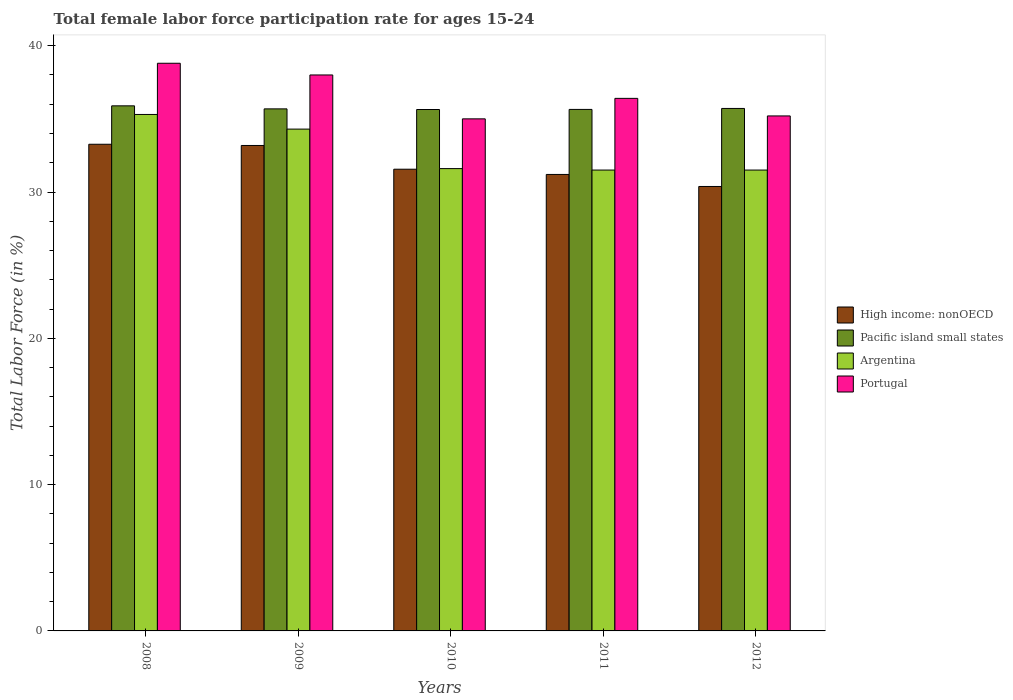Are the number of bars on each tick of the X-axis equal?
Your response must be concise. Yes. How many bars are there on the 5th tick from the left?
Offer a terse response. 4. How many bars are there on the 2nd tick from the right?
Make the answer very short. 4. In how many cases, is the number of bars for a given year not equal to the number of legend labels?
Your response must be concise. 0. What is the female labor force participation rate in Portugal in 2011?
Give a very brief answer. 36.4. Across all years, what is the maximum female labor force participation rate in High income: nonOECD?
Your response must be concise. 33.26. Across all years, what is the minimum female labor force participation rate in High income: nonOECD?
Provide a succinct answer. 30.38. In which year was the female labor force participation rate in High income: nonOECD minimum?
Make the answer very short. 2012. What is the total female labor force participation rate in Argentina in the graph?
Provide a short and direct response. 164.2. What is the difference between the female labor force participation rate in Argentina in 2010 and that in 2012?
Make the answer very short. 0.1. What is the difference between the female labor force participation rate in Pacific island small states in 2009 and the female labor force participation rate in Portugal in 2012?
Offer a terse response. 0.48. What is the average female labor force participation rate in Portugal per year?
Ensure brevity in your answer.  36.68. In the year 2009, what is the difference between the female labor force participation rate in Argentina and female labor force participation rate in High income: nonOECD?
Provide a short and direct response. 1.12. In how many years, is the female labor force participation rate in Argentina greater than 8 %?
Make the answer very short. 5. What is the ratio of the female labor force participation rate in High income: nonOECD in 2011 to that in 2012?
Make the answer very short. 1.03. Is the female labor force participation rate in High income: nonOECD in 2009 less than that in 2010?
Give a very brief answer. No. Is the difference between the female labor force participation rate in Argentina in 2008 and 2010 greater than the difference between the female labor force participation rate in High income: nonOECD in 2008 and 2010?
Make the answer very short. Yes. What is the difference between the highest and the second highest female labor force participation rate in Portugal?
Offer a terse response. 0.8. What is the difference between the highest and the lowest female labor force participation rate in Pacific island small states?
Your answer should be compact. 0.25. Is it the case that in every year, the sum of the female labor force participation rate in Argentina and female labor force participation rate in Portugal is greater than the sum of female labor force participation rate in High income: nonOECD and female labor force participation rate in Pacific island small states?
Ensure brevity in your answer.  Yes. What does the 3rd bar from the left in 2011 represents?
Make the answer very short. Argentina. How many years are there in the graph?
Your response must be concise. 5. Are the values on the major ticks of Y-axis written in scientific E-notation?
Provide a succinct answer. No. Does the graph contain any zero values?
Ensure brevity in your answer.  No. Where does the legend appear in the graph?
Provide a succinct answer. Center right. How many legend labels are there?
Your answer should be compact. 4. How are the legend labels stacked?
Offer a very short reply. Vertical. What is the title of the graph?
Provide a short and direct response. Total female labor force participation rate for ages 15-24. Does "Sudan" appear as one of the legend labels in the graph?
Your response must be concise. No. What is the label or title of the Y-axis?
Your answer should be compact. Total Labor Force (in %). What is the Total Labor Force (in %) of High income: nonOECD in 2008?
Make the answer very short. 33.26. What is the Total Labor Force (in %) of Pacific island small states in 2008?
Make the answer very short. 35.89. What is the Total Labor Force (in %) in Argentina in 2008?
Ensure brevity in your answer.  35.3. What is the Total Labor Force (in %) in Portugal in 2008?
Give a very brief answer. 38.8. What is the Total Labor Force (in %) of High income: nonOECD in 2009?
Your answer should be compact. 33.18. What is the Total Labor Force (in %) in Pacific island small states in 2009?
Your response must be concise. 35.68. What is the Total Labor Force (in %) of Argentina in 2009?
Provide a succinct answer. 34.3. What is the Total Labor Force (in %) in Portugal in 2009?
Offer a very short reply. 38. What is the Total Labor Force (in %) in High income: nonOECD in 2010?
Offer a very short reply. 31.56. What is the Total Labor Force (in %) in Pacific island small states in 2010?
Offer a very short reply. 35.64. What is the Total Labor Force (in %) of Argentina in 2010?
Your response must be concise. 31.6. What is the Total Labor Force (in %) of High income: nonOECD in 2011?
Provide a succinct answer. 31.2. What is the Total Labor Force (in %) of Pacific island small states in 2011?
Ensure brevity in your answer.  35.64. What is the Total Labor Force (in %) in Argentina in 2011?
Your response must be concise. 31.5. What is the Total Labor Force (in %) in Portugal in 2011?
Make the answer very short. 36.4. What is the Total Labor Force (in %) in High income: nonOECD in 2012?
Provide a succinct answer. 30.38. What is the Total Labor Force (in %) of Pacific island small states in 2012?
Your response must be concise. 35.71. What is the Total Labor Force (in %) of Argentina in 2012?
Your response must be concise. 31.5. What is the Total Labor Force (in %) in Portugal in 2012?
Provide a succinct answer. 35.2. Across all years, what is the maximum Total Labor Force (in %) in High income: nonOECD?
Your answer should be very brief. 33.26. Across all years, what is the maximum Total Labor Force (in %) in Pacific island small states?
Your answer should be compact. 35.89. Across all years, what is the maximum Total Labor Force (in %) in Argentina?
Ensure brevity in your answer.  35.3. Across all years, what is the maximum Total Labor Force (in %) in Portugal?
Offer a terse response. 38.8. Across all years, what is the minimum Total Labor Force (in %) of High income: nonOECD?
Your answer should be compact. 30.38. Across all years, what is the minimum Total Labor Force (in %) in Pacific island small states?
Keep it short and to the point. 35.64. Across all years, what is the minimum Total Labor Force (in %) of Argentina?
Keep it short and to the point. 31.5. What is the total Total Labor Force (in %) in High income: nonOECD in the graph?
Your answer should be compact. 159.58. What is the total Total Labor Force (in %) of Pacific island small states in the graph?
Offer a terse response. 178.57. What is the total Total Labor Force (in %) in Argentina in the graph?
Your answer should be very brief. 164.2. What is the total Total Labor Force (in %) of Portugal in the graph?
Your response must be concise. 183.4. What is the difference between the Total Labor Force (in %) in High income: nonOECD in 2008 and that in 2009?
Your answer should be compact. 0.08. What is the difference between the Total Labor Force (in %) of Pacific island small states in 2008 and that in 2009?
Give a very brief answer. 0.21. What is the difference between the Total Labor Force (in %) of Argentina in 2008 and that in 2009?
Provide a succinct answer. 1. What is the difference between the Total Labor Force (in %) in Portugal in 2008 and that in 2009?
Provide a short and direct response. 0.8. What is the difference between the Total Labor Force (in %) in High income: nonOECD in 2008 and that in 2010?
Keep it short and to the point. 1.71. What is the difference between the Total Labor Force (in %) of Pacific island small states in 2008 and that in 2010?
Offer a very short reply. 0.25. What is the difference between the Total Labor Force (in %) of Argentina in 2008 and that in 2010?
Offer a very short reply. 3.7. What is the difference between the Total Labor Force (in %) in Portugal in 2008 and that in 2010?
Give a very brief answer. 3.8. What is the difference between the Total Labor Force (in %) of High income: nonOECD in 2008 and that in 2011?
Your answer should be compact. 2.06. What is the difference between the Total Labor Force (in %) of Pacific island small states in 2008 and that in 2011?
Give a very brief answer. 0.25. What is the difference between the Total Labor Force (in %) of Portugal in 2008 and that in 2011?
Your answer should be compact. 2.4. What is the difference between the Total Labor Force (in %) of High income: nonOECD in 2008 and that in 2012?
Make the answer very short. 2.89. What is the difference between the Total Labor Force (in %) in Pacific island small states in 2008 and that in 2012?
Ensure brevity in your answer.  0.18. What is the difference between the Total Labor Force (in %) of Argentina in 2008 and that in 2012?
Provide a succinct answer. 3.8. What is the difference between the Total Labor Force (in %) of High income: nonOECD in 2009 and that in 2010?
Your answer should be very brief. 1.62. What is the difference between the Total Labor Force (in %) of Pacific island small states in 2009 and that in 2010?
Your answer should be very brief. 0.04. What is the difference between the Total Labor Force (in %) of Argentina in 2009 and that in 2010?
Your answer should be compact. 2.7. What is the difference between the Total Labor Force (in %) in High income: nonOECD in 2009 and that in 2011?
Provide a succinct answer. 1.98. What is the difference between the Total Labor Force (in %) of Pacific island small states in 2009 and that in 2011?
Provide a succinct answer. 0.04. What is the difference between the Total Labor Force (in %) in High income: nonOECD in 2009 and that in 2012?
Keep it short and to the point. 2.8. What is the difference between the Total Labor Force (in %) in Pacific island small states in 2009 and that in 2012?
Your answer should be very brief. -0.03. What is the difference between the Total Labor Force (in %) in Argentina in 2009 and that in 2012?
Ensure brevity in your answer.  2.8. What is the difference between the Total Labor Force (in %) in High income: nonOECD in 2010 and that in 2011?
Ensure brevity in your answer.  0.36. What is the difference between the Total Labor Force (in %) in Pacific island small states in 2010 and that in 2011?
Your answer should be very brief. -0.01. What is the difference between the Total Labor Force (in %) of Portugal in 2010 and that in 2011?
Provide a short and direct response. -1.4. What is the difference between the Total Labor Force (in %) of High income: nonOECD in 2010 and that in 2012?
Your answer should be very brief. 1.18. What is the difference between the Total Labor Force (in %) in Pacific island small states in 2010 and that in 2012?
Ensure brevity in your answer.  -0.07. What is the difference between the Total Labor Force (in %) of Portugal in 2010 and that in 2012?
Give a very brief answer. -0.2. What is the difference between the Total Labor Force (in %) of High income: nonOECD in 2011 and that in 2012?
Keep it short and to the point. 0.82. What is the difference between the Total Labor Force (in %) of Pacific island small states in 2011 and that in 2012?
Give a very brief answer. -0.07. What is the difference between the Total Labor Force (in %) in Argentina in 2011 and that in 2012?
Your answer should be compact. 0. What is the difference between the Total Labor Force (in %) of High income: nonOECD in 2008 and the Total Labor Force (in %) of Pacific island small states in 2009?
Offer a very short reply. -2.42. What is the difference between the Total Labor Force (in %) of High income: nonOECD in 2008 and the Total Labor Force (in %) of Argentina in 2009?
Give a very brief answer. -1.04. What is the difference between the Total Labor Force (in %) in High income: nonOECD in 2008 and the Total Labor Force (in %) in Portugal in 2009?
Offer a very short reply. -4.74. What is the difference between the Total Labor Force (in %) in Pacific island small states in 2008 and the Total Labor Force (in %) in Argentina in 2009?
Your answer should be compact. 1.59. What is the difference between the Total Labor Force (in %) in Pacific island small states in 2008 and the Total Labor Force (in %) in Portugal in 2009?
Offer a terse response. -2.11. What is the difference between the Total Labor Force (in %) of Argentina in 2008 and the Total Labor Force (in %) of Portugal in 2009?
Keep it short and to the point. -2.7. What is the difference between the Total Labor Force (in %) in High income: nonOECD in 2008 and the Total Labor Force (in %) in Pacific island small states in 2010?
Provide a short and direct response. -2.38. What is the difference between the Total Labor Force (in %) in High income: nonOECD in 2008 and the Total Labor Force (in %) in Argentina in 2010?
Ensure brevity in your answer.  1.66. What is the difference between the Total Labor Force (in %) of High income: nonOECD in 2008 and the Total Labor Force (in %) of Portugal in 2010?
Offer a very short reply. -1.74. What is the difference between the Total Labor Force (in %) of Pacific island small states in 2008 and the Total Labor Force (in %) of Argentina in 2010?
Make the answer very short. 4.29. What is the difference between the Total Labor Force (in %) in Pacific island small states in 2008 and the Total Labor Force (in %) in Portugal in 2010?
Offer a terse response. 0.89. What is the difference between the Total Labor Force (in %) of High income: nonOECD in 2008 and the Total Labor Force (in %) of Pacific island small states in 2011?
Ensure brevity in your answer.  -2.38. What is the difference between the Total Labor Force (in %) in High income: nonOECD in 2008 and the Total Labor Force (in %) in Argentina in 2011?
Make the answer very short. 1.76. What is the difference between the Total Labor Force (in %) of High income: nonOECD in 2008 and the Total Labor Force (in %) of Portugal in 2011?
Give a very brief answer. -3.14. What is the difference between the Total Labor Force (in %) of Pacific island small states in 2008 and the Total Labor Force (in %) of Argentina in 2011?
Offer a terse response. 4.39. What is the difference between the Total Labor Force (in %) of Pacific island small states in 2008 and the Total Labor Force (in %) of Portugal in 2011?
Make the answer very short. -0.51. What is the difference between the Total Labor Force (in %) in Argentina in 2008 and the Total Labor Force (in %) in Portugal in 2011?
Your response must be concise. -1.1. What is the difference between the Total Labor Force (in %) of High income: nonOECD in 2008 and the Total Labor Force (in %) of Pacific island small states in 2012?
Ensure brevity in your answer.  -2.45. What is the difference between the Total Labor Force (in %) in High income: nonOECD in 2008 and the Total Labor Force (in %) in Argentina in 2012?
Make the answer very short. 1.76. What is the difference between the Total Labor Force (in %) in High income: nonOECD in 2008 and the Total Labor Force (in %) in Portugal in 2012?
Make the answer very short. -1.94. What is the difference between the Total Labor Force (in %) in Pacific island small states in 2008 and the Total Labor Force (in %) in Argentina in 2012?
Provide a short and direct response. 4.39. What is the difference between the Total Labor Force (in %) in Pacific island small states in 2008 and the Total Labor Force (in %) in Portugal in 2012?
Make the answer very short. 0.69. What is the difference between the Total Labor Force (in %) of Argentina in 2008 and the Total Labor Force (in %) of Portugal in 2012?
Give a very brief answer. 0.1. What is the difference between the Total Labor Force (in %) in High income: nonOECD in 2009 and the Total Labor Force (in %) in Pacific island small states in 2010?
Your answer should be compact. -2.46. What is the difference between the Total Labor Force (in %) in High income: nonOECD in 2009 and the Total Labor Force (in %) in Argentina in 2010?
Your response must be concise. 1.58. What is the difference between the Total Labor Force (in %) in High income: nonOECD in 2009 and the Total Labor Force (in %) in Portugal in 2010?
Your response must be concise. -1.82. What is the difference between the Total Labor Force (in %) in Pacific island small states in 2009 and the Total Labor Force (in %) in Argentina in 2010?
Make the answer very short. 4.08. What is the difference between the Total Labor Force (in %) of Pacific island small states in 2009 and the Total Labor Force (in %) of Portugal in 2010?
Your answer should be very brief. 0.68. What is the difference between the Total Labor Force (in %) of High income: nonOECD in 2009 and the Total Labor Force (in %) of Pacific island small states in 2011?
Provide a succinct answer. -2.46. What is the difference between the Total Labor Force (in %) in High income: nonOECD in 2009 and the Total Labor Force (in %) in Argentina in 2011?
Ensure brevity in your answer.  1.68. What is the difference between the Total Labor Force (in %) in High income: nonOECD in 2009 and the Total Labor Force (in %) in Portugal in 2011?
Offer a very short reply. -3.22. What is the difference between the Total Labor Force (in %) in Pacific island small states in 2009 and the Total Labor Force (in %) in Argentina in 2011?
Offer a terse response. 4.18. What is the difference between the Total Labor Force (in %) of Pacific island small states in 2009 and the Total Labor Force (in %) of Portugal in 2011?
Give a very brief answer. -0.72. What is the difference between the Total Labor Force (in %) of High income: nonOECD in 2009 and the Total Labor Force (in %) of Pacific island small states in 2012?
Offer a terse response. -2.53. What is the difference between the Total Labor Force (in %) in High income: nonOECD in 2009 and the Total Labor Force (in %) in Argentina in 2012?
Keep it short and to the point. 1.68. What is the difference between the Total Labor Force (in %) of High income: nonOECD in 2009 and the Total Labor Force (in %) of Portugal in 2012?
Offer a very short reply. -2.02. What is the difference between the Total Labor Force (in %) of Pacific island small states in 2009 and the Total Labor Force (in %) of Argentina in 2012?
Give a very brief answer. 4.18. What is the difference between the Total Labor Force (in %) in Pacific island small states in 2009 and the Total Labor Force (in %) in Portugal in 2012?
Your answer should be compact. 0.48. What is the difference between the Total Labor Force (in %) of Argentina in 2009 and the Total Labor Force (in %) of Portugal in 2012?
Make the answer very short. -0.9. What is the difference between the Total Labor Force (in %) in High income: nonOECD in 2010 and the Total Labor Force (in %) in Pacific island small states in 2011?
Make the answer very short. -4.09. What is the difference between the Total Labor Force (in %) in High income: nonOECD in 2010 and the Total Labor Force (in %) in Argentina in 2011?
Ensure brevity in your answer.  0.06. What is the difference between the Total Labor Force (in %) in High income: nonOECD in 2010 and the Total Labor Force (in %) in Portugal in 2011?
Your answer should be compact. -4.84. What is the difference between the Total Labor Force (in %) of Pacific island small states in 2010 and the Total Labor Force (in %) of Argentina in 2011?
Make the answer very short. 4.14. What is the difference between the Total Labor Force (in %) in Pacific island small states in 2010 and the Total Labor Force (in %) in Portugal in 2011?
Your answer should be very brief. -0.76. What is the difference between the Total Labor Force (in %) of Argentina in 2010 and the Total Labor Force (in %) of Portugal in 2011?
Your response must be concise. -4.8. What is the difference between the Total Labor Force (in %) of High income: nonOECD in 2010 and the Total Labor Force (in %) of Pacific island small states in 2012?
Provide a short and direct response. -4.15. What is the difference between the Total Labor Force (in %) of High income: nonOECD in 2010 and the Total Labor Force (in %) of Argentina in 2012?
Your response must be concise. 0.06. What is the difference between the Total Labor Force (in %) in High income: nonOECD in 2010 and the Total Labor Force (in %) in Portugal in 2012?
Offer a very short reply. -3.64. What is the difference between the Total Labor Force (in %) of Pacific island small states in 2010 and the Total Labor Force (in %) of Argentina in 2012?
Your answer should be compact. 4.14. What is the difference between the Total Labor Force (in %) in Pacific island small states in 2010 and the Total Labor Force (in %) in Portugal in 2012?
Your response must be concise. 0.44. What is the difference between the Total Labor Force (in %) of High income: nonOECD in 2011 and the Total Labor Force (in %) of Pacific island small states in 2012?
Your response must be concise. -4.51. What is the difference between the Total Labor Force (in %) of High income: nonOECD in 2011 and the Total Labor Force (in %) of Argentina in 2012?
Ensure brevity in your answer.  -0.3. What is the difference between the Total Labor Force (in %) of High income: nonOECD in 2011 and the Total Labor Force (in %) of Portugal in 2012?
Give a very brief answer. -4. What is the difference between the Total Labor Force (in %) of Pacific island small states in 2011 and the Total Labor Force (in %) of Argentina in 2012?
Your response must be concise. 4.14. What is the difference between the Total Labor Force (in %) of Pacific island small states in 2011 and the Total Labor Force (in %) of Portugal in 2012?
Provide a succinct answer. 0.44. What is the difference between the Total Labor Force (in %) in Argentina in 2011 and the Total Labor Force (in %) in Portugal in 2012?
Offer a terse response. -3.7. What is the average Total Labor Force (in %) of High income: nonOECD per year?
Offer a very short reply. 31.92. What is the average Total Labor Force (in %) in Pacific island small states per year?
Your answer should be compact. 35.71. What is the average Total Labor Force (in %) in Argentina per year?
Make the answer very short. 32.84. What is the average Total Labor Force (in %) in Portugal per year?
Keep it short and to the point. 36.68. In the year 2008, what is the difference between the Total Labor Force (in %) in High income: nonOECD and Total Labor Force (in %) in Pacific island small states?
Offer a terse response. -2.63. In the year 2008, what is the difference between the Total Labor Force (in %) in High income: nonOECD and Total Labor Force (in %) in Argentina?
Your answer should be compact. -2.04. In the year 2008, what is the difference between the Total Labor Force (in %) in High income: nonOECD and Total Labor Force (in %) in Portugal?
Your answer should be compact. -5.54. In the year 2008, what is the difference between the Total Labor Force (in %) of Pacific island small states and Total Labor Force (in %) of Argentina?
Ensure brevity in your answer.  0.59. In the year 2008, what is the difference between the Total Labor Force (in %) in Pacific island small states and Total Labor Force (in %) in Portugal?
Ensure brevity in your answer.  -2.91. In the year 2008, what is the difference between the Total Labor Force (in %) in Argentina and Total Labor Force (in %) in Portugal?
Provide a succinct answer. -3.5. In the year 2009, what is the difference between the Total Labor Force (in %) of High income: nonOECD and Total Labor Force (in %) of Pacific island small states?
Keep it short and to the point. -2.5. In the year 2009, what is the difference between the Total Labor Force (in %) of High income: nonOECD and Total Labor Force (in %) of Argentina?
Ensure brevity in your answer.  -1.12. In the year 2009, what is the difference between the Total Labor Force (in %) in High income: nonOECD and Total Labor Force (in %) in Portugal?
Provide a short and direct response. -4.82. In the year 2009, what is the difference between the Total Labor Force (in %) of Pacific island small states and Total Labor Force (in %) of Argentina?
Your answer should be very brief. 1.38. In the year 2009, what is the difference between the Total Labor Force (in %) of Pacific island small states and Total Labor Force (in %) of Portugal?
Provide a short and direct response. -2.32. In the year 2009, what is the difference between the Total Labor Force (in %) in Argentina and Total Labor Force (in %) in Portugal?
Provide a short and direct response. -3.7. In the year 2010, what is the difference between the Total Labor Force (in %) in High income: nonOECD and Total Labor Force (in %) in Pacific island small states?
Your answer should be very brief. -4.08. In the year 2010, what is the difference between the Total Labor Force (in %) of High income: nonOECD and Total Labor Force (in %) of Argentina?
Offer a terse response. -0.04. In the year 2010, what is the difference between the Total Labor Force (in %) in High income: nonOECD and Total Labor Force (in %) in Portugal?
Make the answer very short. -3.44. In the year 2010, what is the difference between the Total Labor Force (in %) of Pacific island small states and Total Labor Force (in %) of Argentina?
Provide a succinct answer. 4.04. In the year 2010, what is the difference between the Total Labor Force (in %) of Pacific island small states and Total Labor Force (in %) of Portugal?
Keep it short and to the point. 0.64. In the year 2010, what is the difference between the Total Labor Force (in %) of Argentina and Total Labor Force (in %) of Portugal?
Make the answer very short. -3.4. In the year 2011, what is the difference between the Total Labor Force (in %) of High income: nonOECD and Total Labor Force (in %) of Pacific island small states?
Ensure brevity in your answer.  -4.44. In the year 2011, what is the difference between the Total Labor Force (in %) of High income: nonOECD and Total Labor Force (in %) of Argentina?
Provide a short and direct response. -0.3. In the year 2011, what is the difference between the Total Labor Force (in %) in High income: nonOECD and Total Labor Force (in %) in Portugal?
Ensure brevity in your answer.  -5.2. In the year 2011, what is the difference between the Total Labor Force (in %) of Pacific island small states and Total Labor Force (in %) of Argentina?
Provide a short and direct response. 4.14. In the year 2011, what is the difference between the Total Labor Force (in %) of Pacific island small states and Total Labor Force (in %) of Portugal?
Offer a very short reply. -0.76. In the year 2011, what is the difference between the Total Labor Force (in %) in Argentina and Total Labor Force (in %) in Portugal?
Make the answer very short. -4.9. In the year 2012, what is the difference between the Total Labor Force (in %) in High income: nonOECD and Total Labor Force (in %) in Pacific island small states?
Provide a short and direct response. -5.33. In the year 2012, what is the difference between the Total Labor Force (in %) of High income: nonOECD and Total Labor Force (in %) of Argentina?
Make the answer very short. -1.12. In the year 2012, what is the difference between the Total Labor Force (in %) in High income: nonOECD and Total Labor Force (in %) in Portugal?
Ensure brevity in your answer.  -4.82. In the year 2012, what is the difference between the Total Labor Force (in %) of Pacific island small states and Total Labor Force (in %) of Argentina?
Give a very brief answer. 4.21. In the year 2012, what is the difference between the Total Labor Force (in %) of Pacific island small states and Total Labor Force (in %) of Portugal?
Offer a terse response. 0.51. In the year 2012, what is the difference between the Total Labor Force (in %) of Argentina and Total Labor Force (in %) of Portugal?
Your answer should be very brief. -3.7. What is the ratio of the Total Labor Force (in %) in High income: nonOECD in 2008 to that in 2009?
Provide a short and direct response. 1. What is the ratio of the Total Labor Force (in %) of Argentina in 2008 to that in 2009?
Your answer should be compact. 1.03. What is the ratio of the Total Labor Force (in %) of Portugal in 2008 to that in 2009?
Offer a very short reply. 1.02. What is the ratio of the Total Labor Force (in %) in High income: nonOECD in 2008 to that in 2010?
Give a very brief answer. 1.05. What is the ratio of the Total Labor Force (in %) of Pacific island small states in 2008 to that in 2010?
Make the answer very short. 1.01. What is the ratio of the Total Labor Force (in %) of Argentina in 2008 to that in 2010?
Your answer should be compact. 1.12. What is the ratio of the Total Labor Force (in %) in Portugal in 2008 to that in 2010?
Offer a terse response. 1.11. What is the ratio of the Total Labor Force (in %) of High income: nonOECD in 2008 to that in 2011?
Ensure brevity in your answer.  1.07. What is the ratio of the Total Labor Force (in %) of Argentina in 2008 to that in 2011?
Keep it short and to the point. 1.12. What is the ratio of the Total Labor Force (in %) of Portugal in 2008 to that in 2011?
Your answer should be very brief. 1.07. What is the ratio of the Total Labor Force (in %) of High income: nonOECD in 2008 to that in 2012?
Ensure brevity in your answer.  1.09. What is the ratio of the Total Labor Force (in %) in Argentina in 2008 to that in 2012?
Offer a very short reply. 1.12. What is the ratio of the Total Labor Force (in %) of Portugal in 2008 to that in 2012?
Give a very brief answer. 1.1. What is the ratio of the Total Labor Force (in %) of High income: nonOECD in 2009 to that in 2010?
Provide a succinct answer. 1.05. What is the ratio of the Total Labor Force (in %) of Pacific island small states in 2009 to that in 2010?
Your answer should be very brief. 1. What is the ratio of the Total Labor Force (in %) of Argentina in 2009 to that in 2010?
Give a very brief answer. 1.09. What is the ratio of the Total Labor Force (in %) of Portugal in 2009 to that in 2010?
Give a very brief answer. 1.09. What is the ratio of the Total Labor Force (in %) of High income: nonOECD in 2009 to that in 2011?
Offer a very short reply. 1.06. What is the ratio of the Total Labor Force (in %) of Pacific island small states in 2009 to that in 2011?
Give a very brief answer. 1. What is the ratio of the Total Labor Force (in %) of Argentina in 2009 to that in 2011?
Give a very brief answer. 1.09. What is the ratio of the Total Labor Force (in %) in Portugal in 2009 to that in 2011?
Give a very brief answer. 1.04. What is the ratio of the Total Labor Force (in %) of High income: nonOECD in 2009 to that in 2012?
Ensure brevity in your answer.  1.09. What is the ratio of the Total Labor Force (in %) in Argentina in 2009 to that in 2012?
Give a very brief answer. 1.09. What is the ratio of the Total Labor Force (in %) of Portugal in 2009 to that in 2012?
Your answer should be compact. 1.08. What is the ratio of the Total Labor Force (in %) of High income: nonOECD in 2010 to that in 2011?
Your response must be concise. 1.01. What is the ratio of the Total Labor Force (in %) in Pacific island small states in 2010 to that in 2011?
Give a very brief answer. 1. What is the ratio of the Total Labor Force (in %) of Argentina in 2010 to that in 2011?
Provide a short and direct response. 1. What is the ratio of the Total Labor Force (in %) of Portugal in 2010 to that in 2011?
Your response must be concise. 0.96. What is the ratio of the Total Labor Force (in %) in High income: nonOECD in 2010 to that in 2012?
Provide a short and direct response. 1.04. What is the ratio of the Total Labor Force (in %) of Pacific island small states in 2010 to that in 2012?
Give a very brief answer. 1. What is the ratio of the Total Labor Force (in %) in Portugal in 2010 to that in 2012?
Your answer should be compact. 0.99. What is the ratio of the Total Labor Force (in %) of High income: nonOECD in 2011 to that in 2012?
Provide a succinct answer. 1.03. What is the ratio of the Total Labor Force (in %) in Argentina in 2011 to that in 2012?
Give a very brief answer. 1. What is the ratio of the Total Labor Force (in %) of Portugal in 2011 to that in 2012?
Keep it short and to the point. 1.03. What is the difference between the highest and the second highest Total Labor Force (in %) in High income: nonOECD?
Offer a terse response. 0.08. What is the difference between the highest and the second highest Total Labor Force (in %) in Pacific island small states?
Your answer should be compact. 0.18. What is the difference between the highest and the lowest Total Labor Force (in %) in High income: nonOECD?
Offer a very short reply. 2.89. What is the difference between the highest and the lowest Total Labor Force (in %) of Pacific island small states?
Provide a short and direct response. 0.25. What is the difference between the highest and the lowest Total Labor Force (in %) of Argentina?
Ensure brevity in your answer.  3.8. 